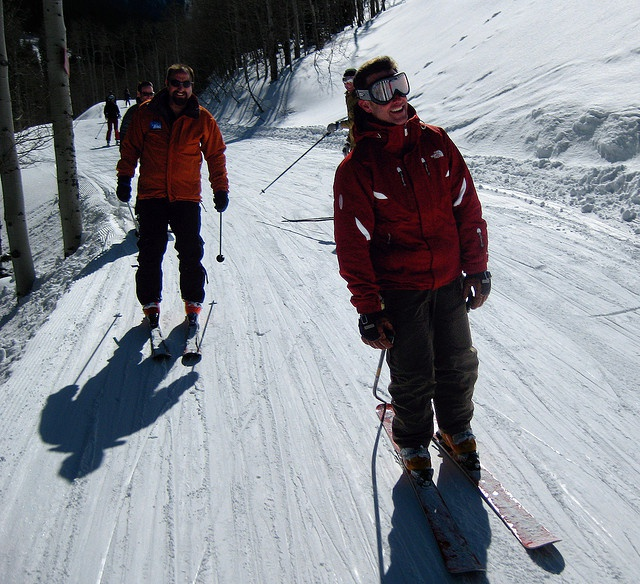Describe the objects in this image and their specific colors. I can see people in black, maroon, gray, and darkgray tones, people in black, maroon, navy, and gray tones, skis in black, darkgray, lightgray, and navy tones, skis in black, darkgray, navy, and gray tones, and people in black, gray, darkgray, and maroon tones in this image. 